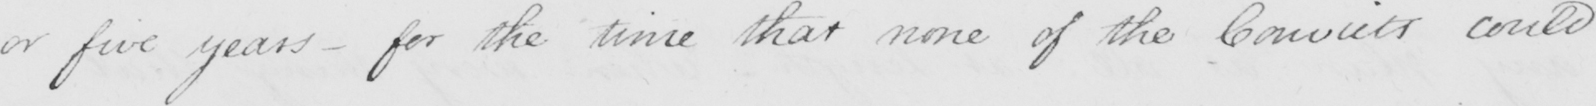Can you read and transcribe this handwriting? or five years  _  for the time that none of the Convicts could 